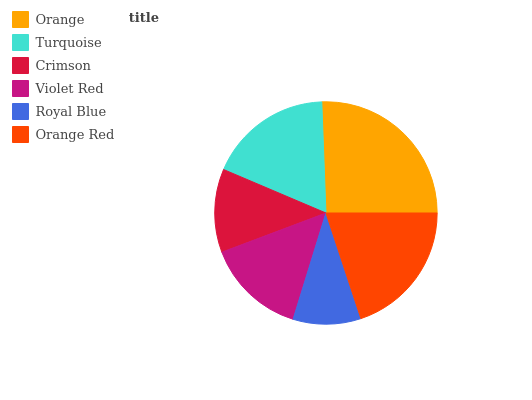Is Royal Blue the minimum?
Answer yes or no. Yes. Is Orange the maximum?
Answer yes or no. Yes. Is Turquoise the minimum?
Answer yes or no. No. Is Turquoise the maximum?
Answer yes or no. No. Is Orange greater than Turquoise?
Answer yes or no. Yes. Is Turquoise less than Orange?
Answer yes or no. Yes. Is Turquoise greater than Orange?
Answer yes or no. No. Is Orange less than Turquoise?
Answer yes or no. No. Is Turquoise the high median?
Answer yes or no. Yes. Is Violet Red the low median?
Answer yes or no. Yes. Is Orange the high median?
Answer yes or no. No. Is Royal Blue the low median?
Answer yes or no. No. 